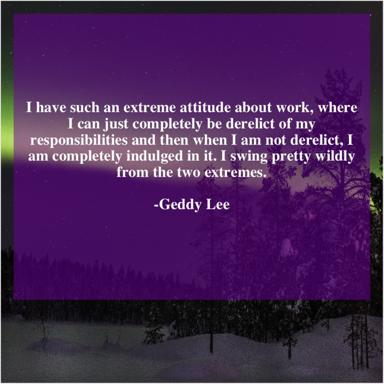Who is Geddy Lee? Geddy Lee is a prominent Canadian musician acclaimed for his role as the lead vocalist, bassist, and keyboardist in the rock band Rush. Renowned for his unique vocal style and masterful bass techniques, Lee has made significant contributions to the world of rock music and remains an influential figure in the industry. 